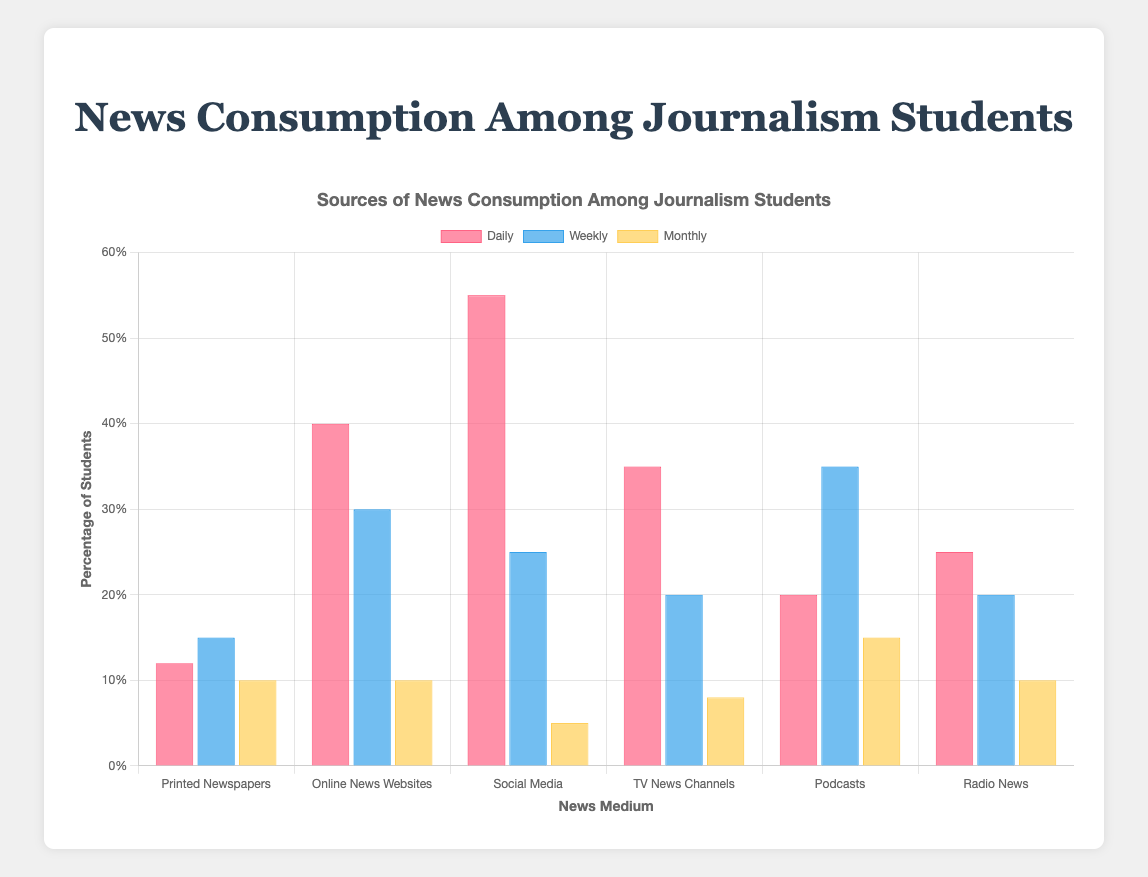How frequently do journalism students get their news from social media on a weekly basis? Look at the bar representing social media and choose the one labeled "Weekly". The height of this bar shows the percentage of students getting their news weekly from social media.
Answer: 25% Which medium has the highest daily usage among journalism students? Check the bars for each medium labeled "Daily". The tallest bar indicates the medium with the highest daily usage.
Answer: Social Media What's the sum of the percentages for journalism students who consume news from podcasts on a daily and weekly basis? Locate the bars for podcasts and find those labeled "Daily" and "Weekly". Add these percentages together: 20% (Daily) + 35% (Weekly).
Answer: 55% Is the usage of printed newspapers on a monthly basis greater than the daily usage of TV news channels? Compare the heights of the bars representing printed newspapers on a monthly basis and TV news channels on a daily basis.
Answer: No What percentage of journalism students listen to radio news daily? Look at the bar representing radio news and check the one labeled "Daily". The height of this bar shows the percentage.
Answer: 25% Among podcasts, which frequency category is the most popular? Identify the tallest bar among those representing the frequency categories (Daily, Weekly, Monthly) for podcasts.
Answer: Weekly How much higher is the percentage of students getting daily news from social media compared to those getting daily news from online news websites? Find the bars for social media and online news websites marked "Daily". Subtract the percentage for online news websites from that for social media: 55% - 40%.
Answer: 15% Are there any mediums with an equal percentage of monthly news consumption? Compare the heights of the bars for each medium labeled "Monthly". Identify any medium pairs with the same percentage.
Answer: Yes, printed newspapers, online news websites, and radio news each have 10% Which frequency category for sources of news has the lowest percentage across all mediums? Identify the smallest bars for each frequency category (Daily, Weekly, Monthly) and compare their percentages.
Answer: Monthly (Social Media at 5%) 